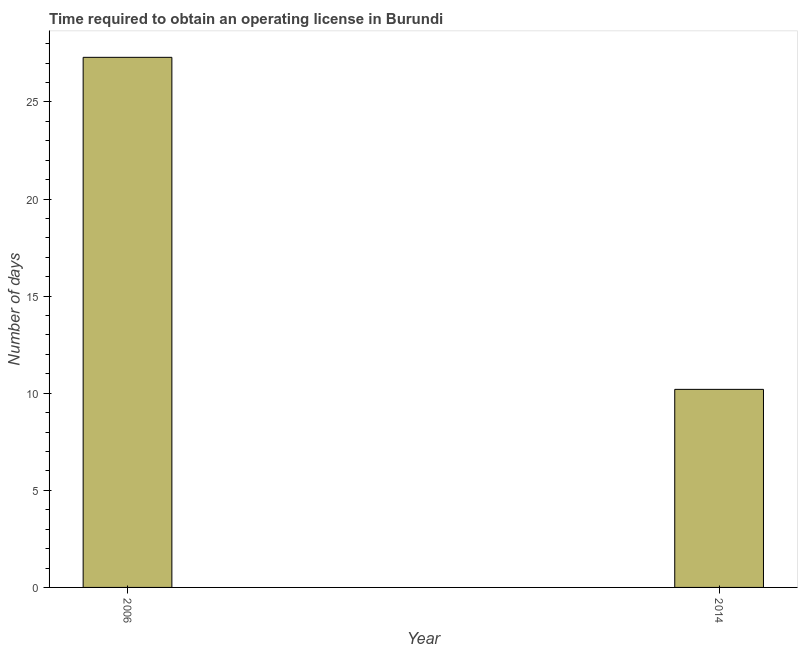Does the graph contain grids?
Offer a very short reply. No. What is the title of the graph?
Offer a terse response. Time required to obtain an operating license in Burundi. What is the label or title of the X-axis?
Keep it short and to the point. Year. What is the label or title of the Y-axis?
Your answer should be very brief. Number of days. What is the number of days to obtain operating license in 2006?
Provide a succinct answer. 27.3. Across all years, what is the maximum number of days to obtain operating license?
Give a very brief answer. 27.3. In which year was the number of days to obtain operating license minimum?
Offer a very short reply. 2014. What is the sum of the number of days to obtain operating license?
Your answer should be compact. 37.5. What is the average number of days to obtain operating license per year?
Keep it short and to the point. 18.75. What is the median number of days to obtain operating license?
Your response must be concise. 18.75. In how many years, is the number of days to obtain operating license greater than 15 days?
Give a very brief answer. 1. Do a majority of the years between 2014 and 2006 (inclusive) have number of days to obtain operating license greater than 6 days?
Your answer should be compact. No. What is the ratio of the number of days to obtain operating license in 2006 to that in 2014?
Provide a succinct answer. 2.68. Is the number of days to obtain operating license in 2006 less than that in 2014?
Ensure brevity in your answer.  No. How many bars are there?
Provide a short and direct response. 2. What is the difference between two consecutive major ticks on the Y-axis?
Provide a short and direct response. 5. What is the Number of days in 2006?
Provide a succinct answer. 27.3. What is the Number of days in 2014?
Offer a terse response. 10.2. What is the difference between the Number of days in 2006 and 2014?
Give a very brief answer. 17.1. What is the ratio of the Number of days in 2006 to that in 2014?
Your response must be concise. 2.68. 